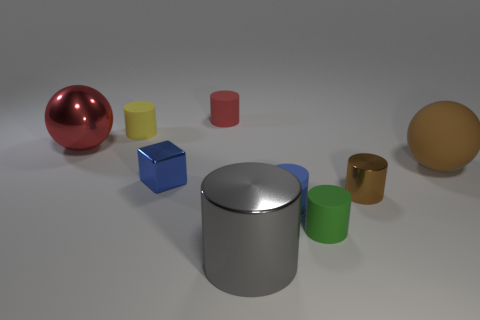How do the different colors of the objects influence their visual perception? The varying colors of the objects create a distinct visual effect. Bright colors like yellow and red attract the viewer's attention more readily, while cooler colors like blue and green have a calmer presence. Color contrasts also highlight the spatial arrangement, making some objects stand out more and giving the scene a sense of depth and diversity. 